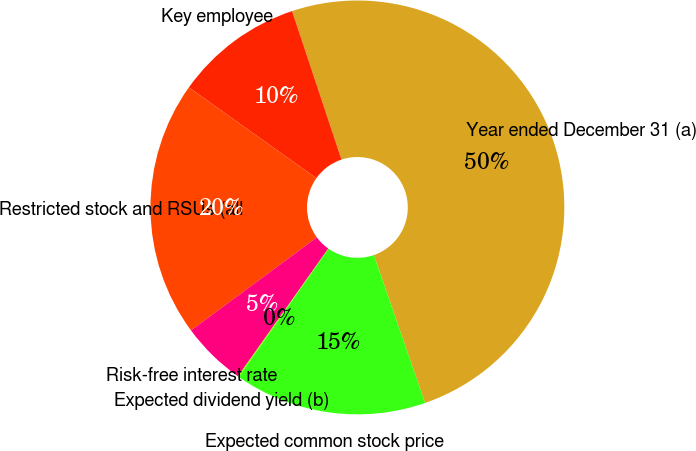Convert chart. <chart><loc_0><loc_0><loc_500><loc_500><pie_chart><fcel>Year ended December 31 (a)<fcel>Key employee<fcel>Restricted stock and RSUs (all<fcel>Risk-free interest rate<fcel>Expected dividend yield (b)<fcel>Expected common stock price<nl><fcel>49.81%<fcel>10.04%<fcel>19.98%<fcel>5.07%<fcel>0.09%<fcel>15.01%<nl></chart> 